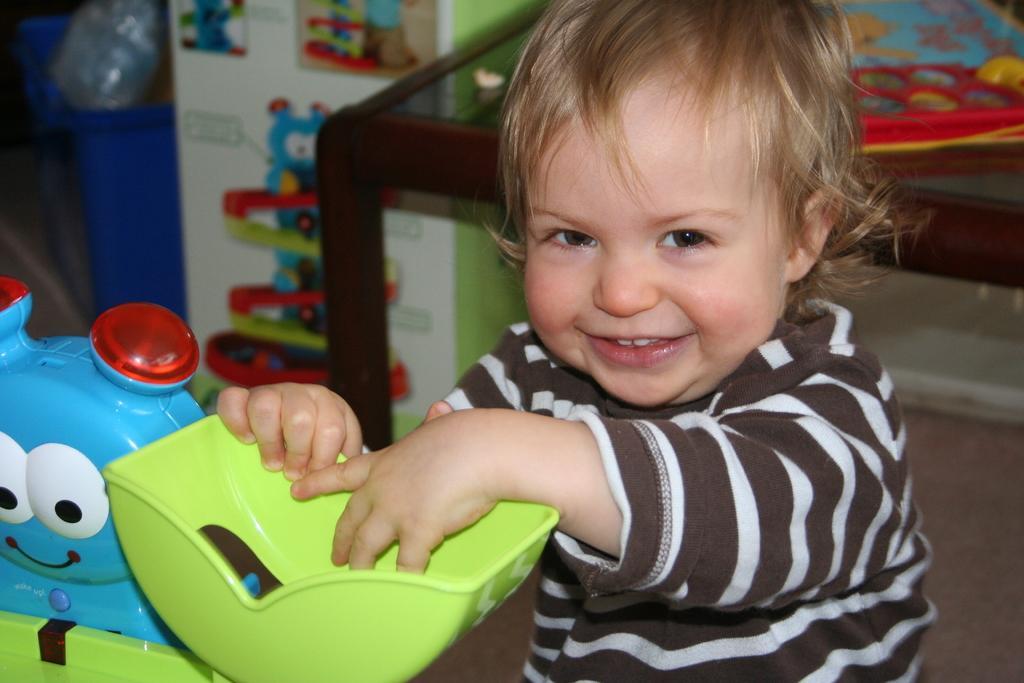How would you summarize this image in a sentence or two? In this image there is a kid. The kid is smiling. In front of the kid there are toys. Behind the kid there is a table. There are objects on the table. In the background there is a wall. 